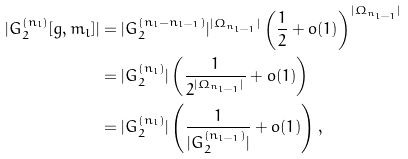<formula> <loc_0><loc_0><loc_500><loc_500>| G _ { 2 } ^ { ( n _ { l } ) } [ g , m _ { l } ] | & = | G _ { 2 } ^ { ( n _ { l } - n _ { l - 1 } ) } | ^ { | \Omega _ { n _ { l - 1 } } | } \left ( \frac { 1 } { 2 } + o ( 1 ) \right ) ^ { | \Omega _ { n _ { l - 1 } } | } \\ & = | G _ { 2 } ^ { ( n _ { l } ) } | \left ( \frac { 1 } { 2 ^ { | \Omega _ { n _ { l - 1 } } | } } + o ( 1 ) \right ) \\ & = | G _ { 2 } ^ { ( n _ { l } ) } | \left ( \frac { 1 } { | G _ { 2 } ^ { ( n _ { l - 1 } ) } | } + o ( 1 ) \right ) ,</formula> 